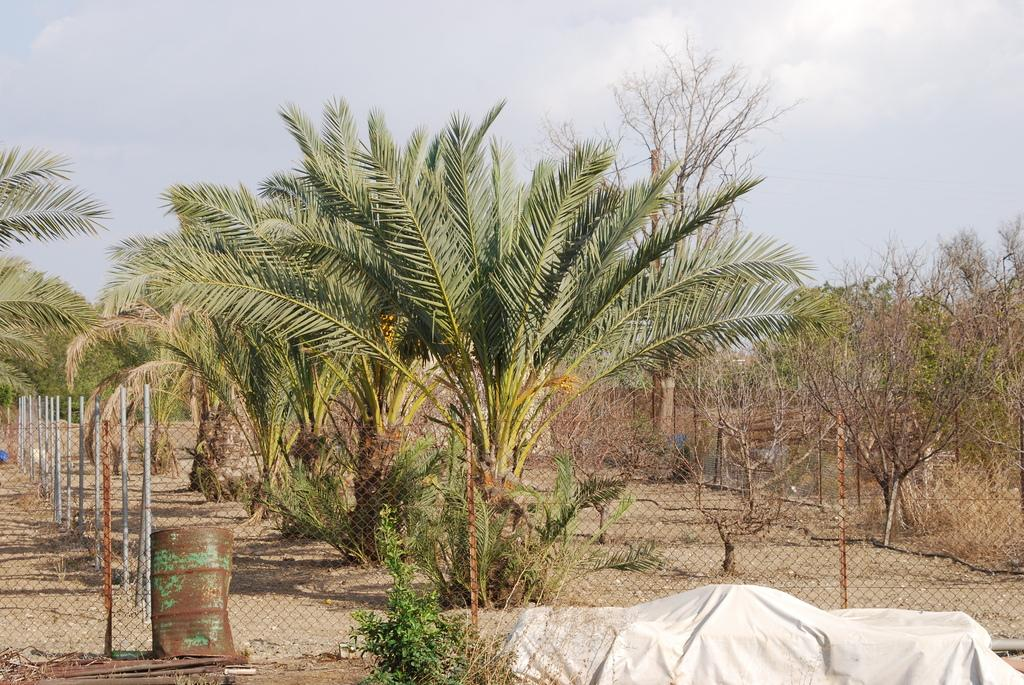What is located in the center of the image? There are trees, a fence, a barrel, and plants in the center of the image. What is the color of the blanket in the center of the image? The blanket in the center of the image is white. What can be seen in the background of the image? The sky is visible in the background of the image, and clouds are present. What type of canvas is being used as a floor in the image? There is no canvas or floor present in the image; it features trees, a fence, a barrel, plants, a white blanket, the sky, and clouds. Is there a playground visible in the image? There is no playground present in the image. 